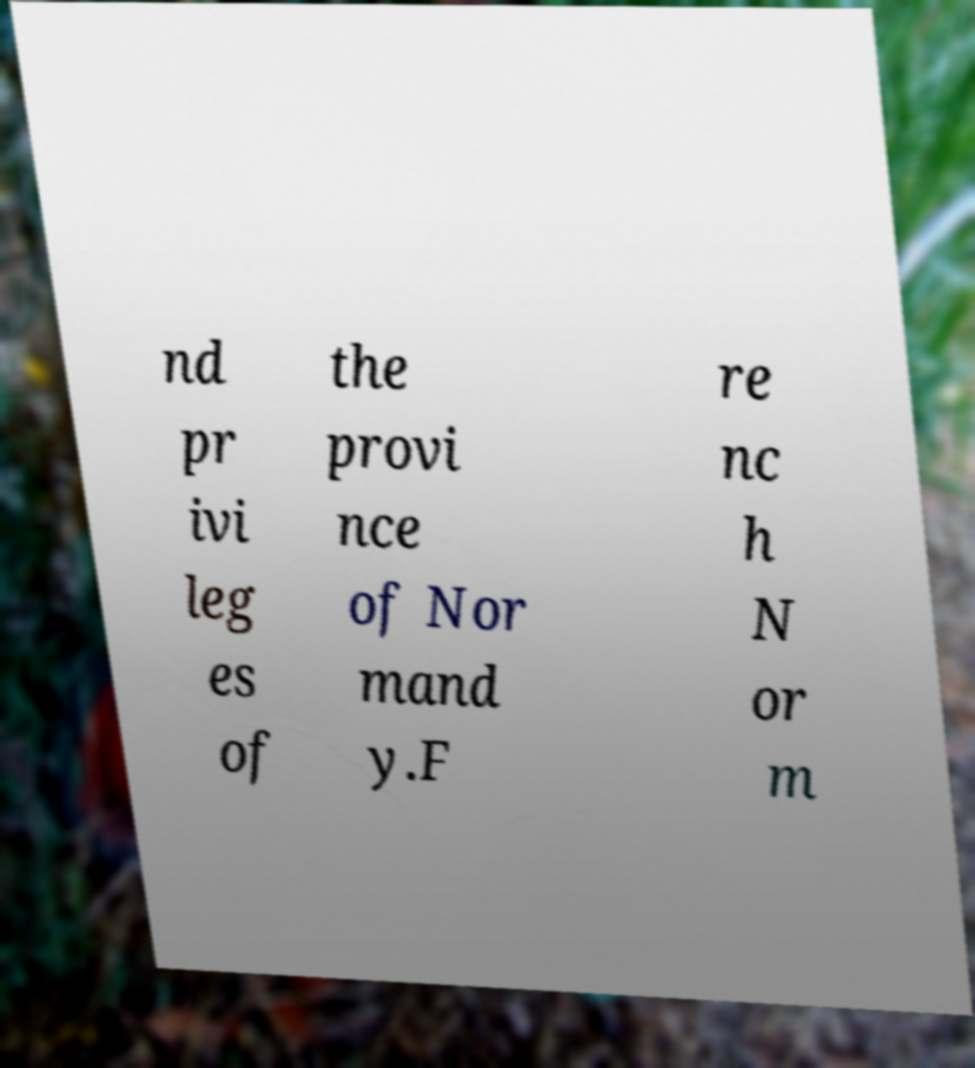Could you extract and type out the text from this image? nd pr ivi leg es of the provi nce of Nor mand y.F re nc h N or m 